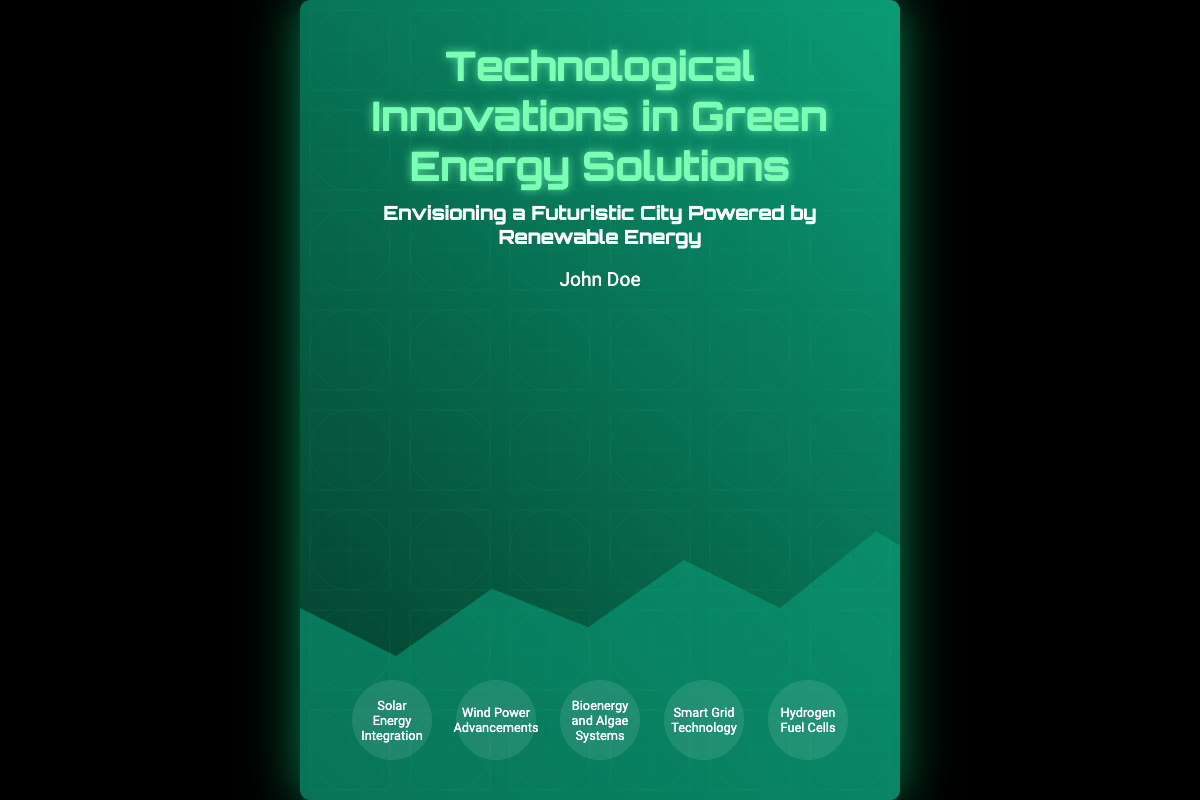What is the title of the book? The title of the book is prominently displayed at the top of the cover.
Answer: Technological Innovations in Green Energy Solutions Who is the author of the book? The author's name is mentioned in the designated area for the author on the cover.
Answer: John Doe What is the subtitle of the book? The subtitle is located below the main title and provides additional context about the book's focus.
Answer: Envisioning a Futuristic City Powered by Renewable Energy How many highlight items are listed on the cover? The highlights section displays several key topics, and the number can be counted visually.
Answer: Five What color is used for the title of the book? The title's color can be clearly seen in the text on the cover.
Answer: Light green What is one of the highlight topics related to energy? The highlights section includes topics that address advancements in renewable energy sources.
Answer: Solar Energy Integration What type of graphics are included in the background? The cover features a specific design element that enhances its visual appeal and relevance to the theme.
Answer: Circuitry patterns What is the overall background color scheme of the book cover? The color scheme of the cover can be determined by examining the gradient used in the design.
Answer: Dark green gradient 